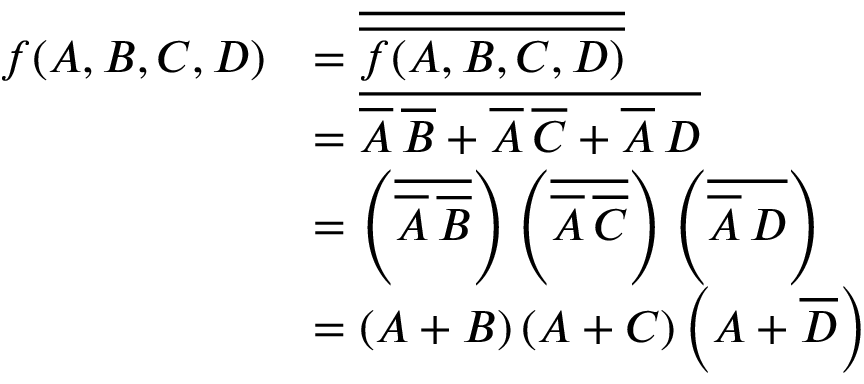Convert formula to latex. <formula><loc_0><loc_0><loc_500><loc_500>{ \begin{array} { r l } { f ( A , B , C , D ) } & { = { \overline { { \overline { f ( A , B , C , D ) } } } } } \\ & { = { \overline { { { \overline { A } } \, { \overline { B } } + { \overline { A } } \, { \overline { C } } + { \overline { A } } \, D } } } } \\ & { = \left ( { \overline { { { \overline { A } } \, { \overline { B } } } } } \right ) \left ( { \overline { { { \overline { A } } \, { \overline { C } } } } } \right ) \left ( { \overline { { { \overline { A } } \, D } } } \right ) } \\ & { = \left ( A + B \right ) \left ( A + C \right ) \left ( A + { \overline { D } } \right ) } \end{array} }</formula> 